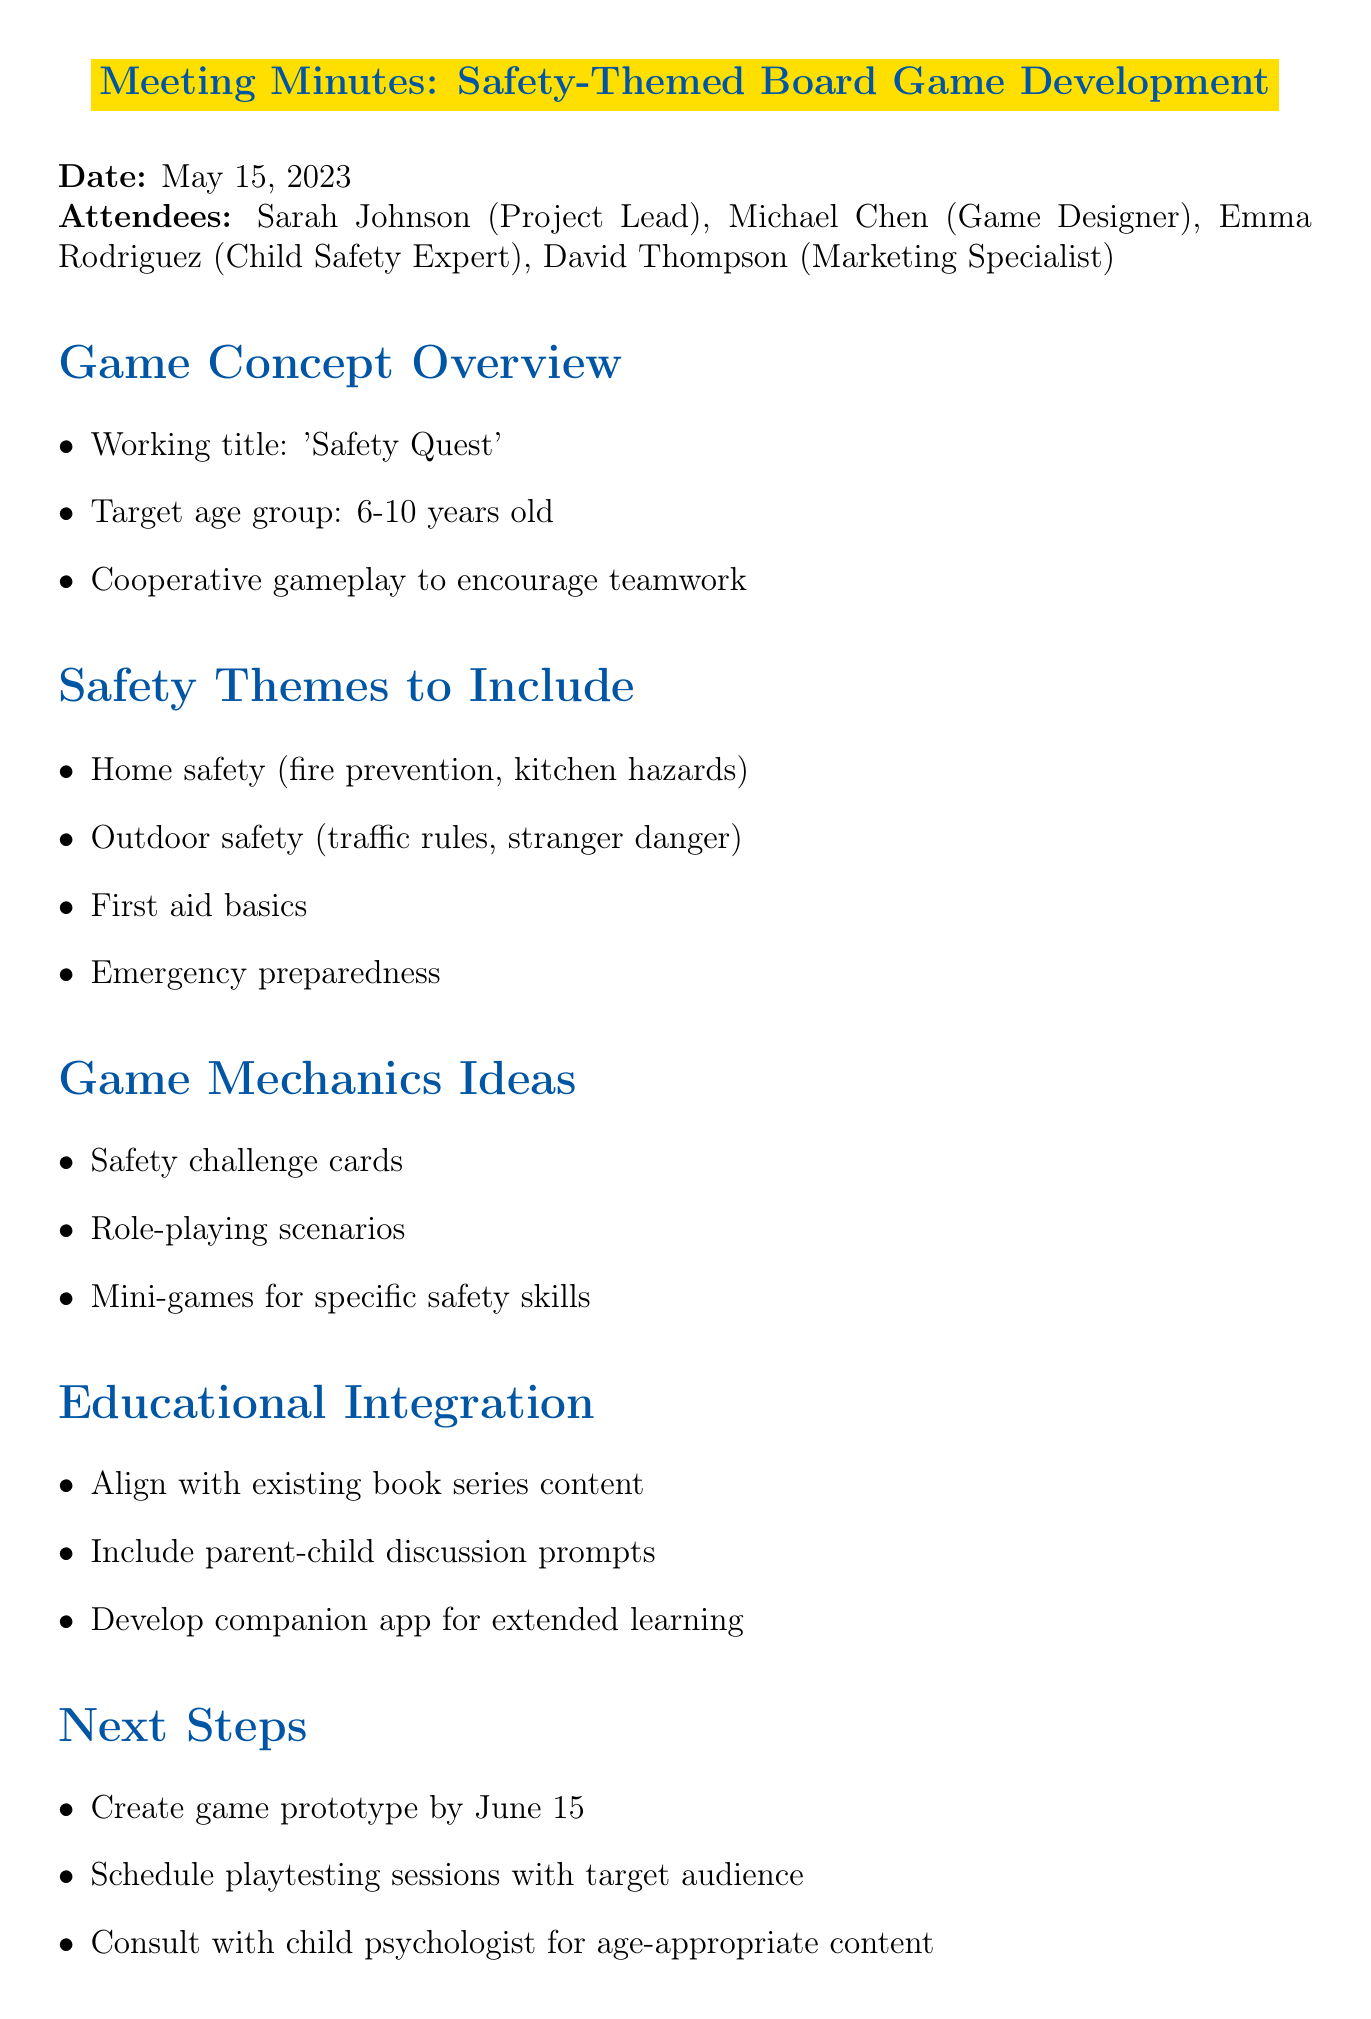What is the working title of the game? The working title can be found in the Game Concept Overview section of the document.
Answer: Safety Quest Who is the project lead? The project lead is listed in the attendees section of the document.
Answer: Sarah Johnson What age group is the game targeted at? The target age group can be found in the Game Concept Overview section of the document.
Answer: 6-10 years old What safety theme relates to traffic rules? This theme is mentioned under the Safety Themes to Include section of the document.
Answer: Outdoor safety Who is responsible for drafting the initial game rules? The assignee for this task can be found in the Action Items section of the document.
Answer: Michael Chen When is the game prototype due? The due date for the prototype is mentioned in the Next Steps section of the document.
Answer: June 15 What type of gameplay is encouraged in the game? This gameplay style is indicated in the Game Concept Overview section of the document.
Answer: Cooperative gameplay What should be included for educational integration? This requirement is listed in the Educational Integration section of the document.
Answer: Parent-child discussion prompts What is the due date for compiling the list of safety topics? The due date for this task can be found in the Action Items section of the document.
Answer: May 22, 2023 